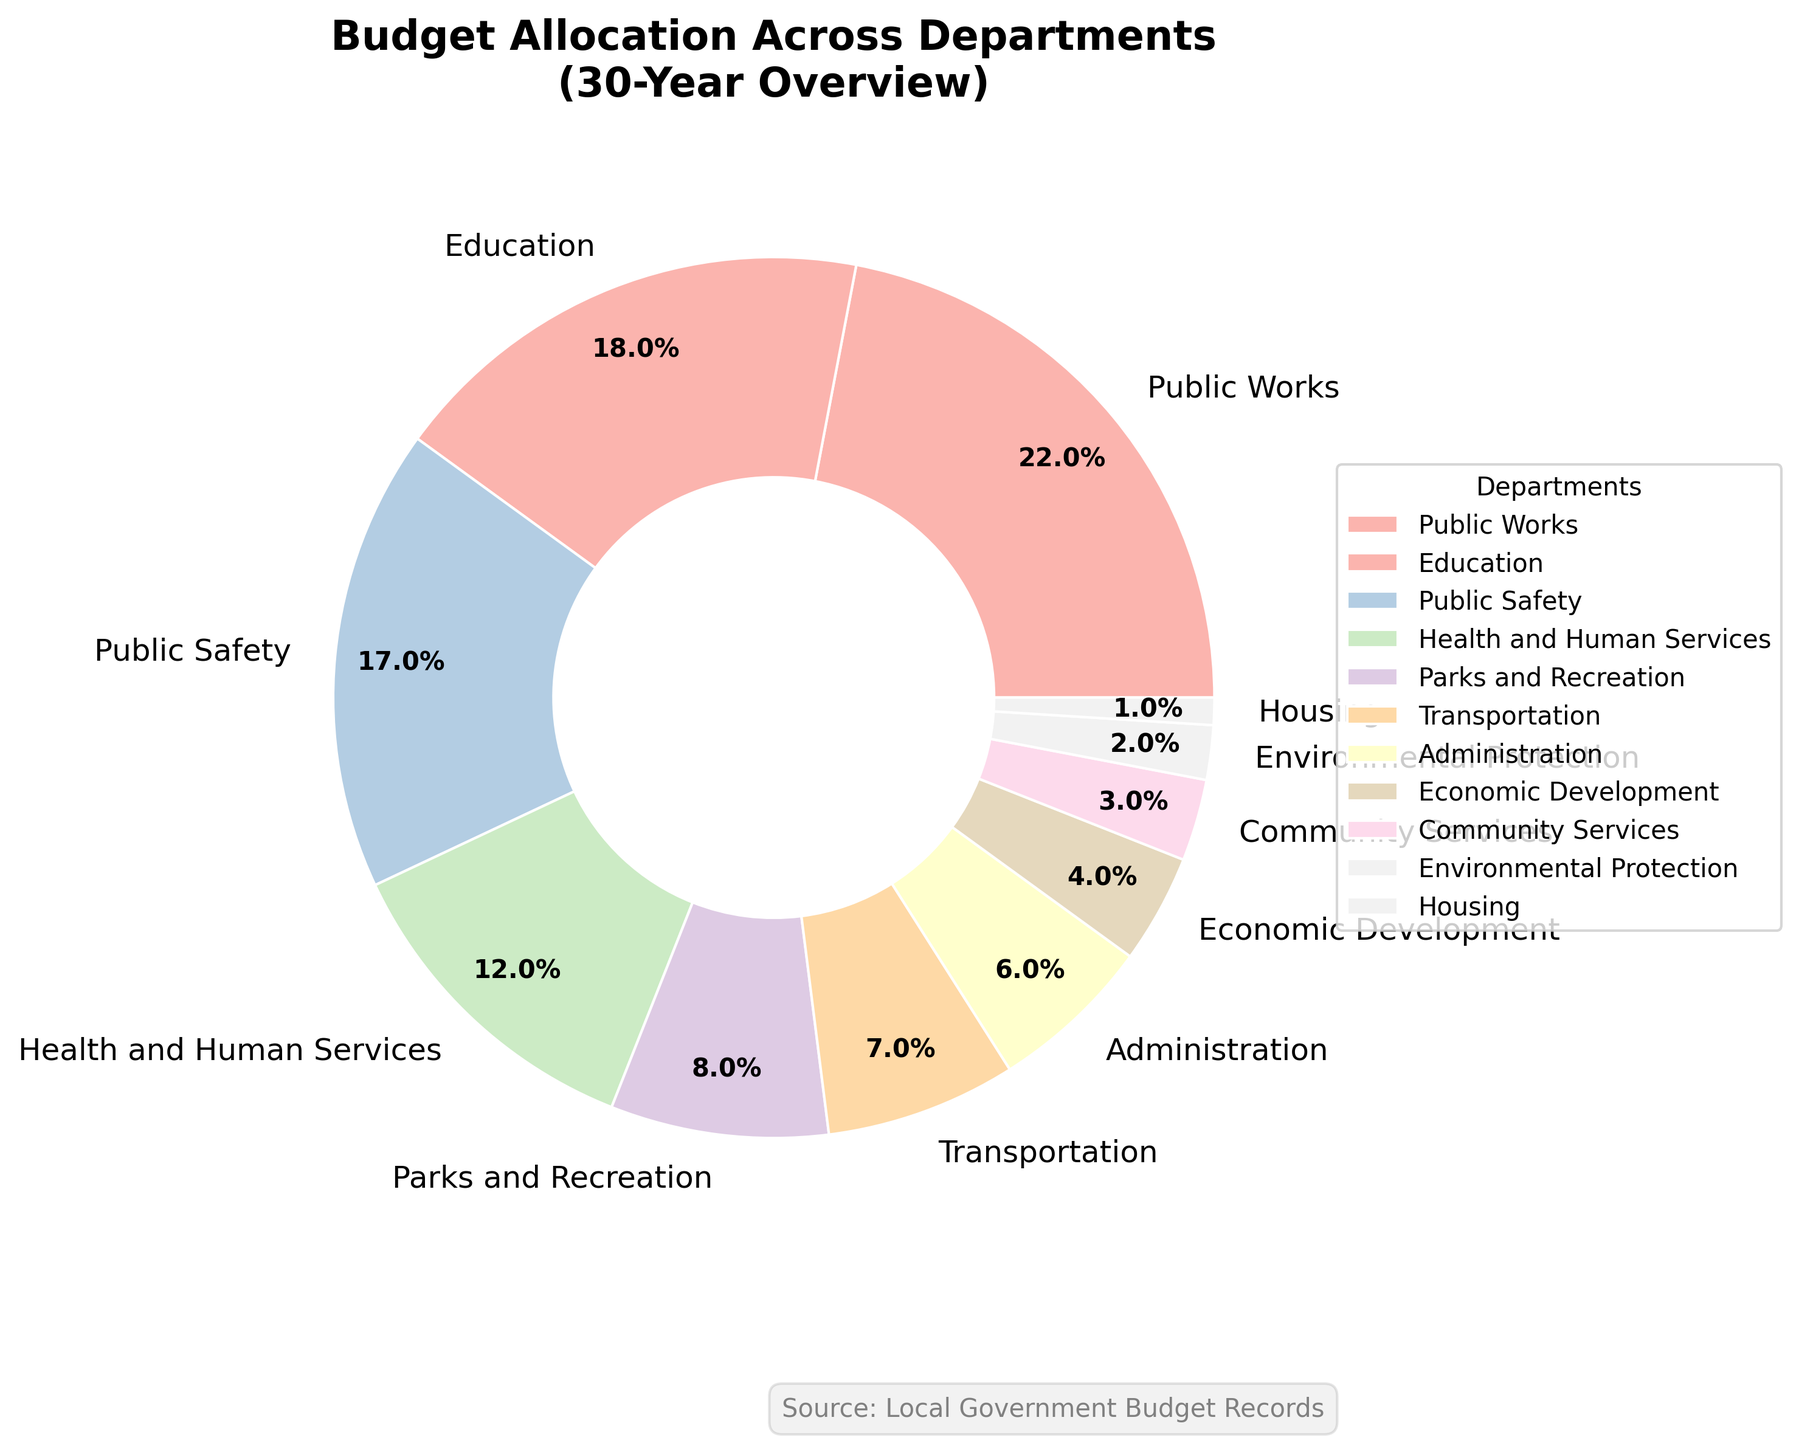What's the largest budget allocation among the departments? The pie chart shows that the largest slice of the pie is for Public Works, with a 22% budget allocation.
Answer: Public Works Which department has a smaller budget allocation: Public Safety or Education? By looking at the pie chart, we can see the sizes of the slices for Public Safety and Education. Public Safety has a 17% allocation, and Education has an 18% allocation.
Answer: Public Safety What's the combined budget allocation for Health and Human Services and Community Services? The percentages for Health and Human Services and Community Services are 12% and 3%, respectively. Adding these percentages together gives us 12 + 3 = 15.
Answer: 15% Which department has a 1% budget allocation? From the pie chart, the department labeled with a 1% budget allocation is Housing.
Answer: Housing Is the budget allocation for Transportation greater than or less than Parks and Recreation? In the pie chart, Parks and Recreation has an 8% allocation, while Transportation has a 7% allocation. 7% is less than 8%.
Answer: Less than What is the total budget allocation percentage for Environmental Protection, Economic Development, and Administration? The allocation percentages for Environmental Protection, Economic Development, and Administration are 2%, 4%, and 6%, respectively. Summing these gives us 2 + 4 + 6 = 12.
Answer: 12% How many departments have budget allocations smaller than 5%? From the pie chart, Economic Development (4%), Community Services (3%), Environmental Protection (2%), and Housing (1%) have allocations smaller than 5%. There are 4 such departments.
Answer: 4 Which department has the third-largest budget allocation? The pie chart shows that the third-largest slice of the pie, after Public Works (22%) and Education (18%), is Public Safety with a 17% allocation.
Answer: Public Safety What's the difference in budget allocation between Education and Housing? The pie chart indicates that Education has an 18% allocation and Housing has a 1% allocation. The difference is 18 - 1 = 17.
Answer: 17% Among the departments with less than 10% allocation, which one has the largest allocation? Among Transportation (7%), Administration (6%), Economic Development (4%), Community Services (3%), Environmental Protection (2%), and Housing (1%), Parks and Recreation has the largest allocation at 8%.
Answer: Parks and Recreation 